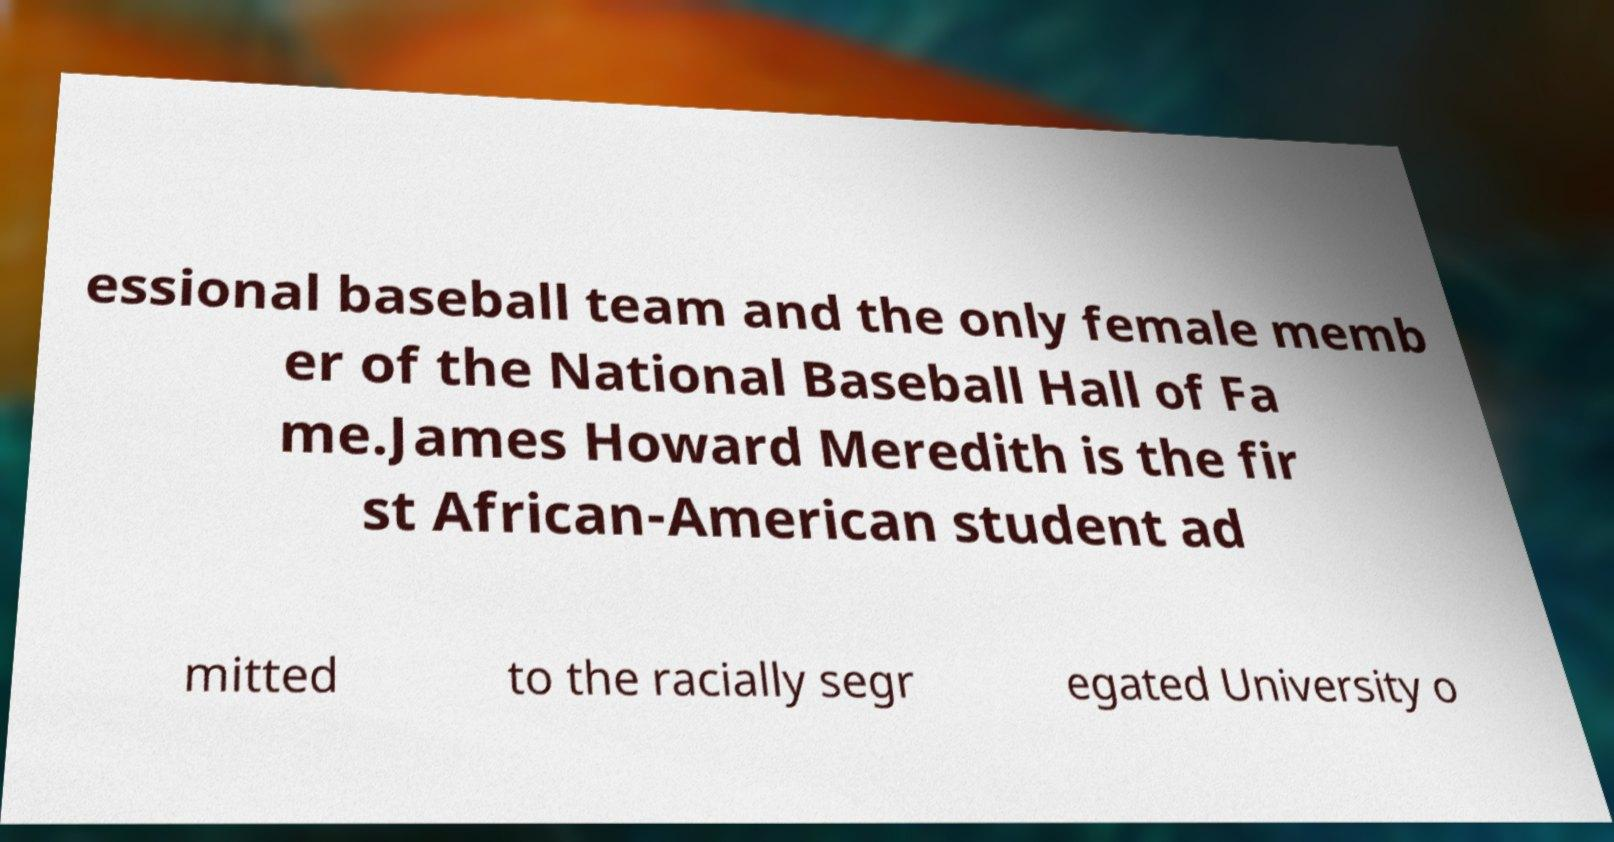Could you assist in decoding the text presented in this image and type it out clearly? essional baseball team and the only female memb er of the National Baseball Hall of Fa me.James Howard Meredith is the fir st African-American student ad mitted to the racially segr egated University o 